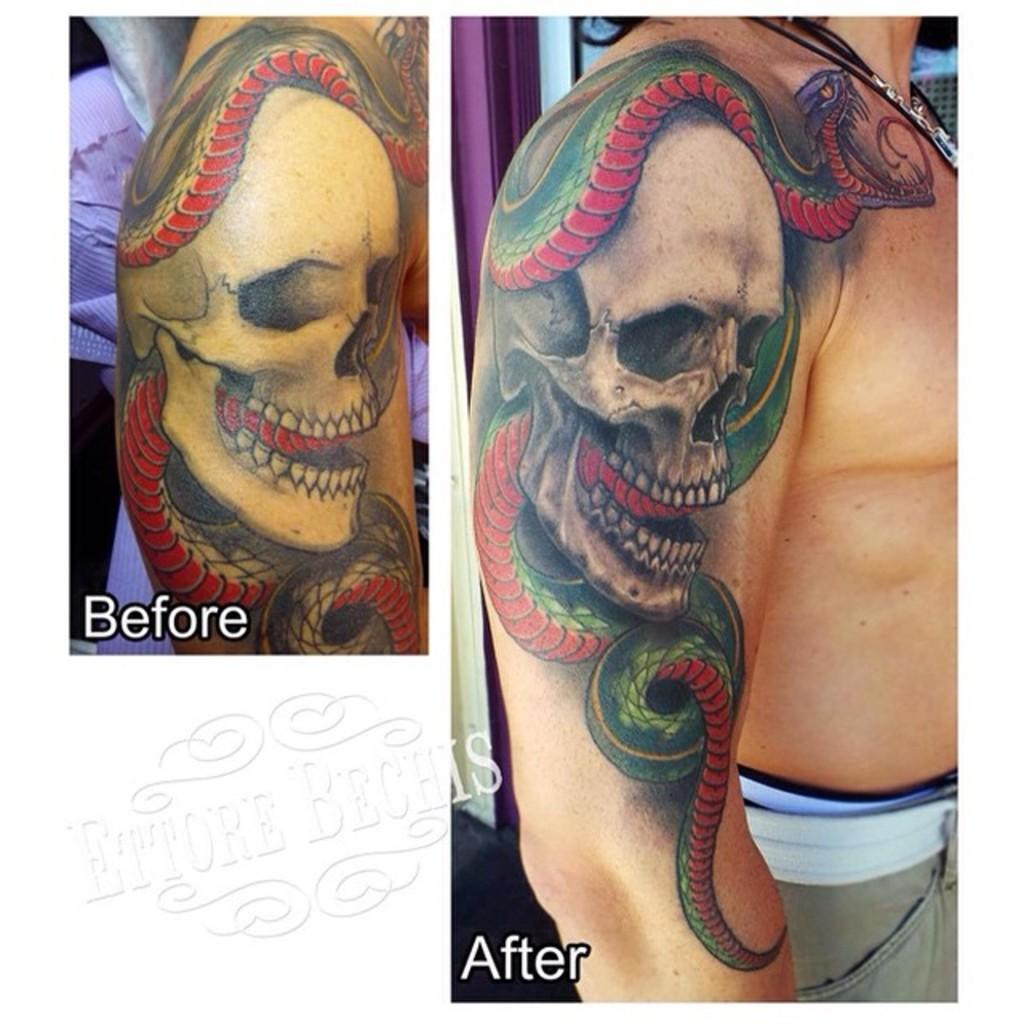What is the composition of the image? The image is a collage of two images. What can be seen on a hand in the image? There is a tattoo on a hand in the image. What is depicted in the tattoo? The tattoo contains a skull and a snake above the skull. What is the price of the tattoo in the image? The price of the tattoo is not mentioned in the image, as it is a visual representation and not a commercial advertisement. How does the snake wrap around the throat in the tattoo? There is no snake wrapping around a throat in the tattoo; the snake is depicted above the skull. 